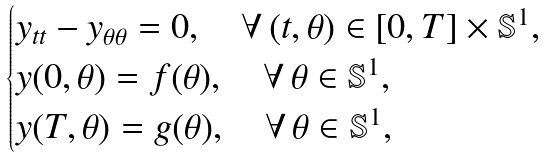Convert formula to latex. <formula><loc_0><loc_0><loc_500><loc_500>\begin{cases} y _ { t t } - y _ { \theta \theta } = 0 , \quad \forall \, ( t , \theta ) \in [ 0 , T ] \times \mathbb { S } ^ { 1 } , \\ y ( 0 , \theta ) = f ( \theta ) , \quad \forall \, \theta \in \mathbb { S } ^ { 1 } , \\ y ( T , \theta ) = g ( \theta ) , \quad \forall \, \theta \in \mathbb { S } ^ { 1 } , \end{cases}</formula> 